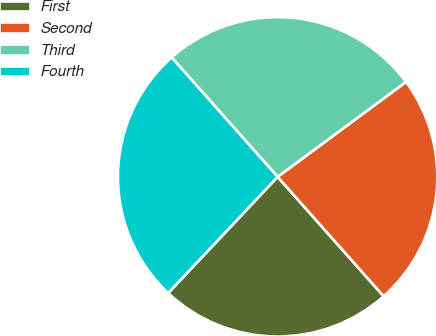Convert chart. <chart><loc_0><loc_0><loc_500><loc_500><pie_chart><fcel>First<fcel>Second<fcel>Third<fcel>Fourth<nl><fcel>23.58%<fcel>23.58%<fcel>26.42%<fcel>26.42%<nl></chart> 